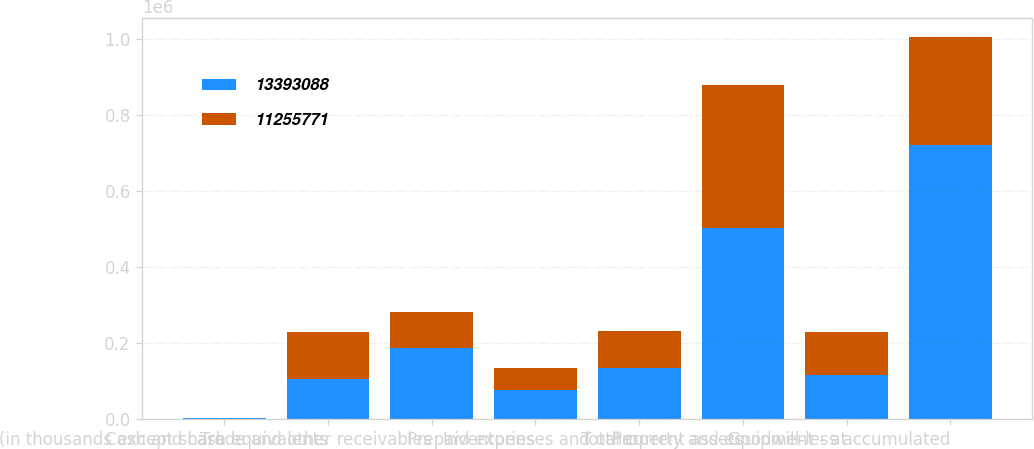<chart> <loc_0><loc_0><loc_500><loc_500><stacked_bar_chart><ecel><fcel>(in thousands except share<fcel>Cash and cash equivalents<fcel>Trade and other receivables<fcel>Inventories<fcel>Prepaid expenses and other<fcel>Total current assets<fcel>Property and equipment - at<fcel>Goodwill-less accumulated<nl><fcel>1.33931e+07<fcel>2006<fcel>104520<fcel>185886<fcel>76969<fcel>134529<fcel>501904<fcel>114952<fcel>721514<nl><fcel>1.12558e+07<fcel>2005<fcel>125385<fcel>95254<fcel>57803<fcel>98568<fcel>377010<fcel>114952<fcel>283133<nl></chart> 